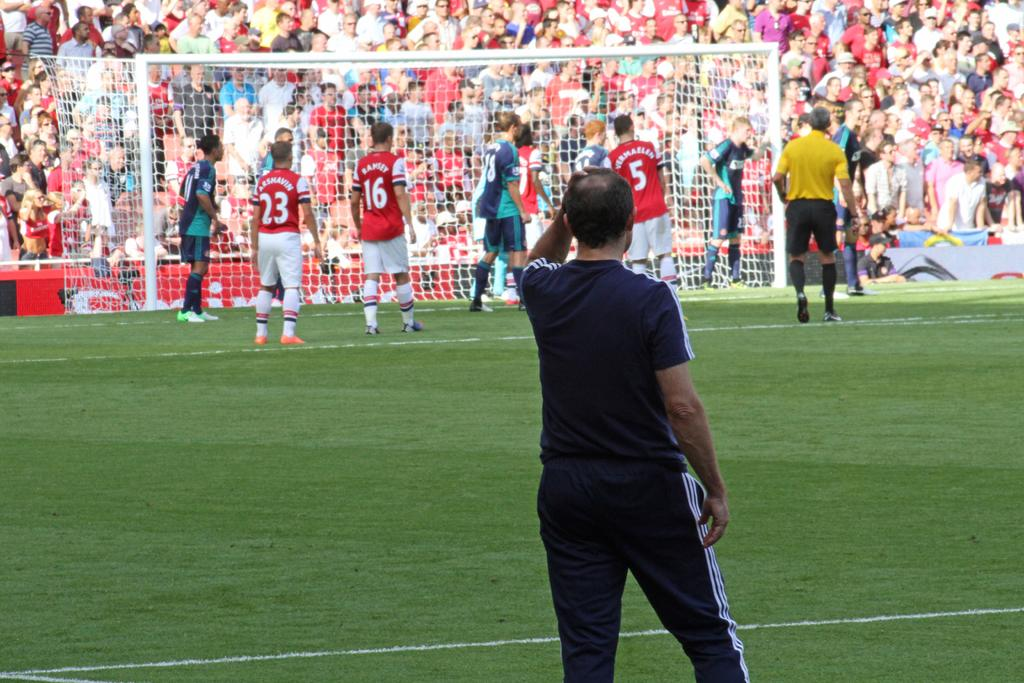What is the person in the image doing? The person is standing on the ground. What type of surface is the person standing on? The ground has grass. What can be seen in the background of the image? There are many people in the background. What structure is present in the image? There is a goal post in the image. What type of competition is taking place between the pots in the image? There are no pots present in the image, and therefore no competition can be observed. 